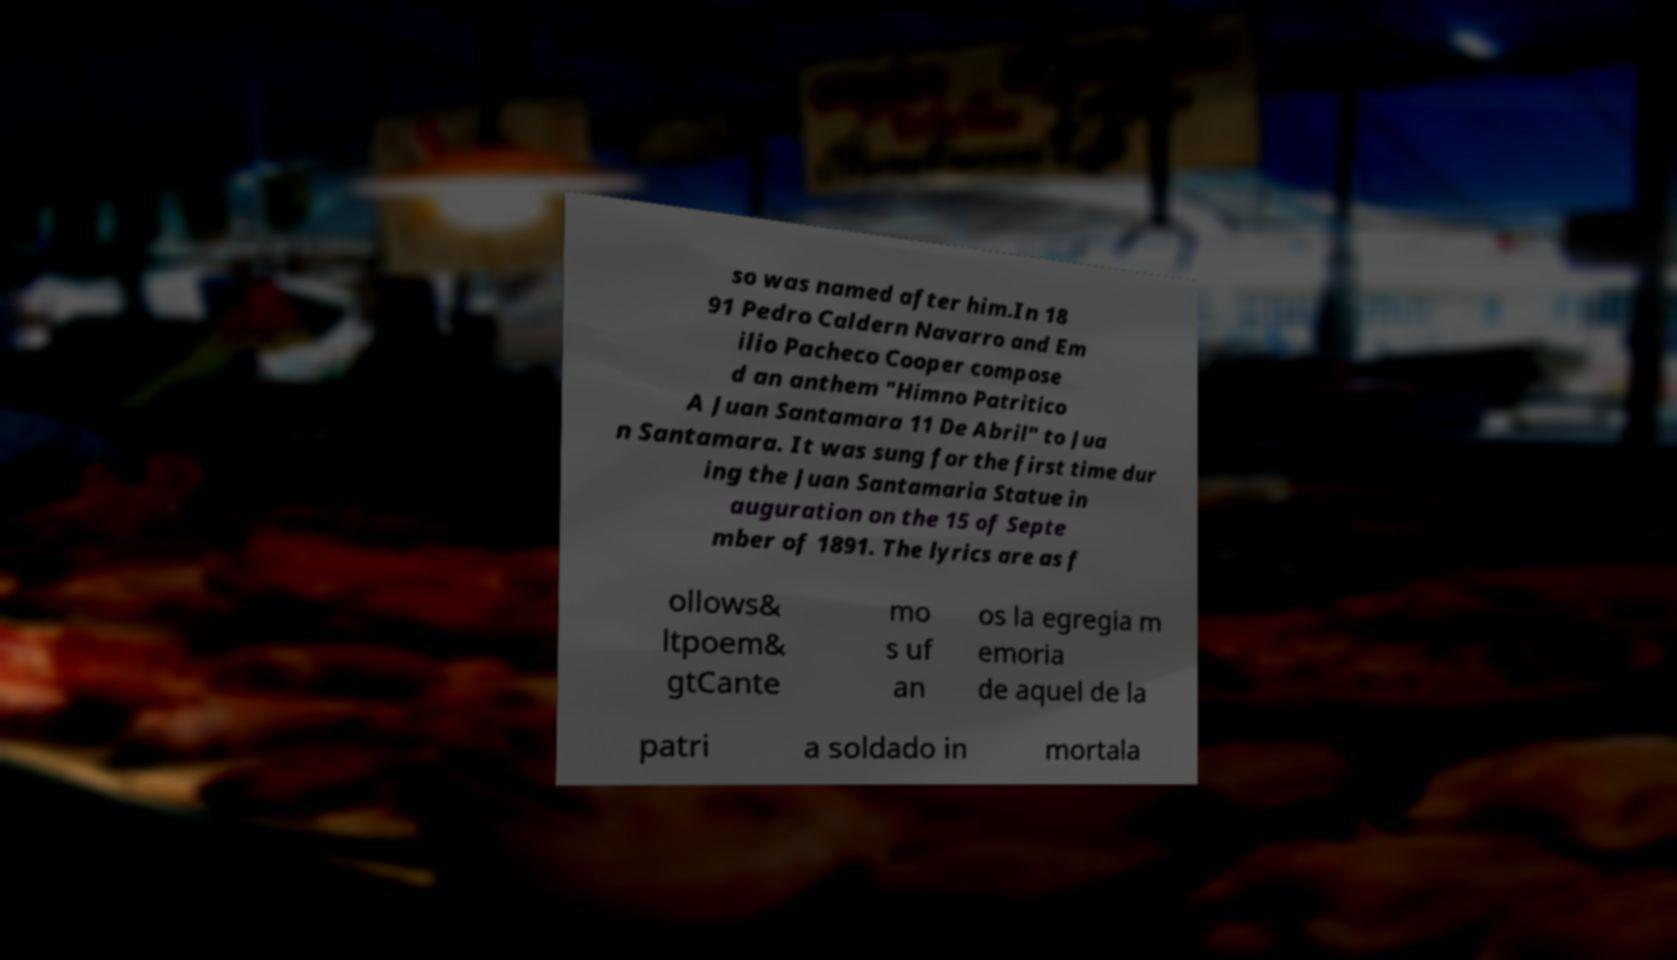For documentation purposes, I need the text within this image transcribed. Could you provide that? so was named after him.In 18 91 Pedro Caldern Navarro and Em ilio Pacheco Cooper compose d an anthem "Himno Patritico A Juan Santamara 11 De Abril" to Jua n Santamara. It was sung for the first time dur ing the Juan Santamaria Statue in auguration on the 15 of Septe mber of 1891. The lyrics are as f ollows& ltpoem& gtCante mo s uf an os la egregia m emoria de aquel de la patri a soldado in mortala 